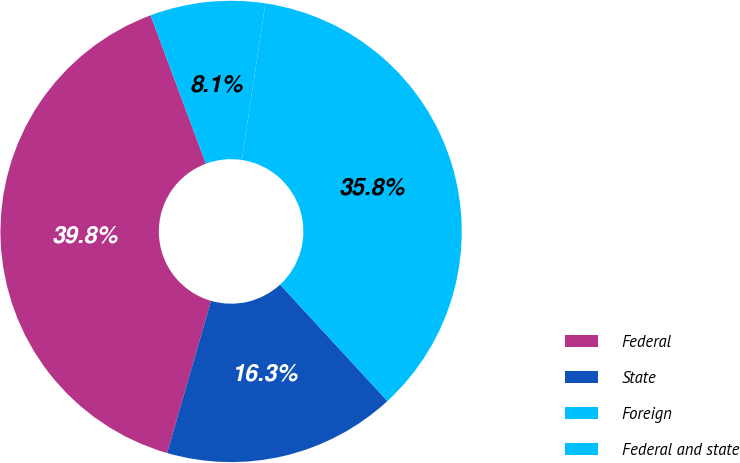Convert chart. <chart><loc_0><loc_0><loc_500><loc_500><pie_chart><fcel>Federal<fcel>State<fcel>Foreign<fcel>Federal and state<nl><fcel>39.85%<fcel>16.33%<fcel>35.77%<fcel>8.05%<nl></chart> 